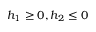Convert formula to latex. <formula><loc_0><loc_0><loc_500><loc_500>h _ { 1 } \geq 0 , h _ { 2 } \leq 0</formula> 